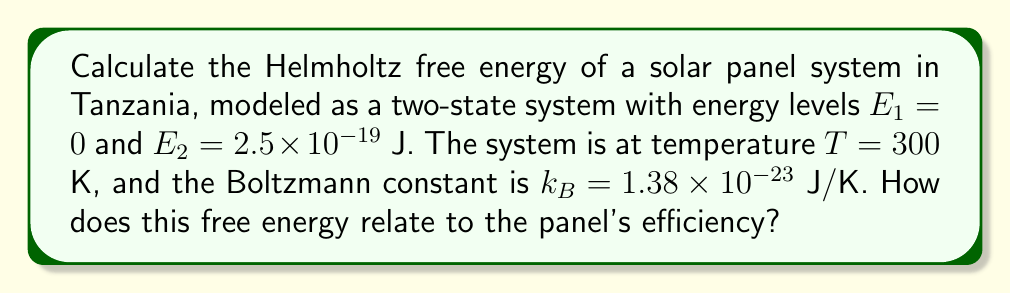Could you help me with this problem? Let's approach this step-by-step:

1) The Helmholtz free energy is given by:
   $$F = -k_B T \ln Z$$
   where $Z$ is the partition function.

2) For a two-state system, the partition function is:
   $$Z = e^{-\beta E_1} + e^{-\beta E_2}$$
   where $\beta = \frac{1}{k_B T}$

3) Calculate $\beta$:
   $$\beta = \frac{1}{(1.38 \times 10^{-23})(300)} = 2.415 \times 10^{20} \text{ J}^{-1}$$

4) Now, let's calculate $Z$:
   $$Z = e^{-\beta E_1} + e^{-\beta E_2}$$
   $$Z = e^0 + e^{-(2.415 \times 10^{20})(2.5 \times 10^{-19})}$$
   $$Z = 1 + e^{-60.375} \approx 1 + 5.645 \times 10^{-27} \approx 1$$

5) Now we can calculate the free energy:
   $$F = -k_B T \ln Z$$
   $$F = -(1.38 \times 10^{-23})(300)\ln(1)$$
   $$F = 0 \text{ J}$$

6) Interpretation: The free energy being zero indicates that the system is in its ground state, which is optimal for energy conversion. This suggests high efficiency for the solar panel, as it can readily absorb incoming photons to excite electrons to the higher energy state.
Answer: $F = 0$ J, indicating high potential efficiency 